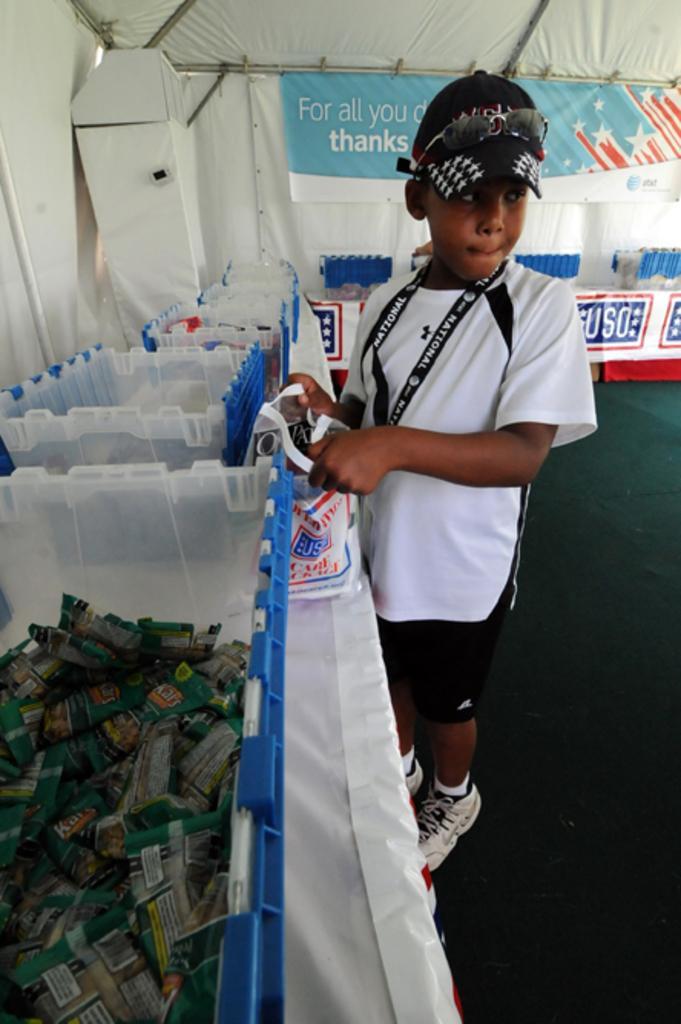Could you give a brief overview of what you see in this image? In this picture we can see a boy standing on the floor besides the table. And there is a white color cloth on the table. He wear a cap and he has goggles on it. he hold a camera with his hand. He wear a white shoe. And on the table there are containers. This is the tent and there is a banner attached it. These are the packets in a container. 